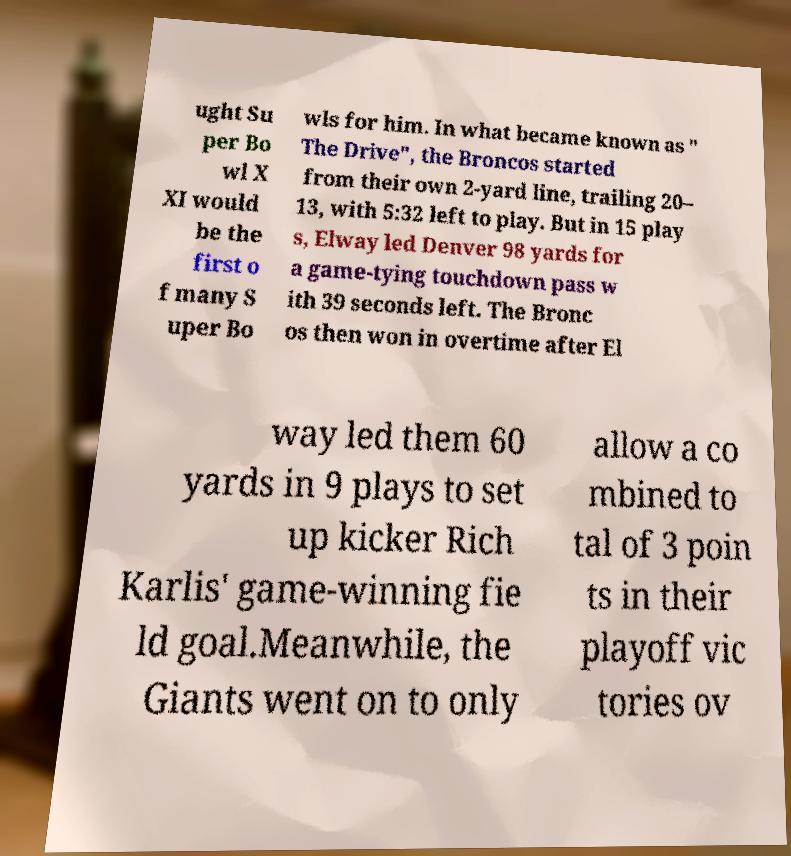I need the written content from this picture converted into text. Can you do that? ught Su per Bo wl X XI would be the first o f many S uper Bo wls for him. In what became known as " The Drive", the Broncos started from their own 2-yard line, trailing 20– 13, with 5:32 left to play. But in 15 play s, Elway led Denver 98 yards for a game-tying touchdown pass w ith 39 seconds left. The Bronc os then won in overtime after El way led them 60 yards in 9 plays to set up kicker Rich Karlis' game-winning fie ld goal.Meanwhile, the Giants went on to only allow a co mbined to tal of 3 poin ts in their playoff vic tories ov 